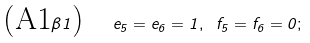<formula> <loc_0><loc_0><loc_500><loc_500>\text {(A1} \beta 1 \text {) \ \ } e _ { 5 } = e _ { 6 } = 1 , \text { } f _ { 5 } = f _ { 6 } = 0 ;</formula> 